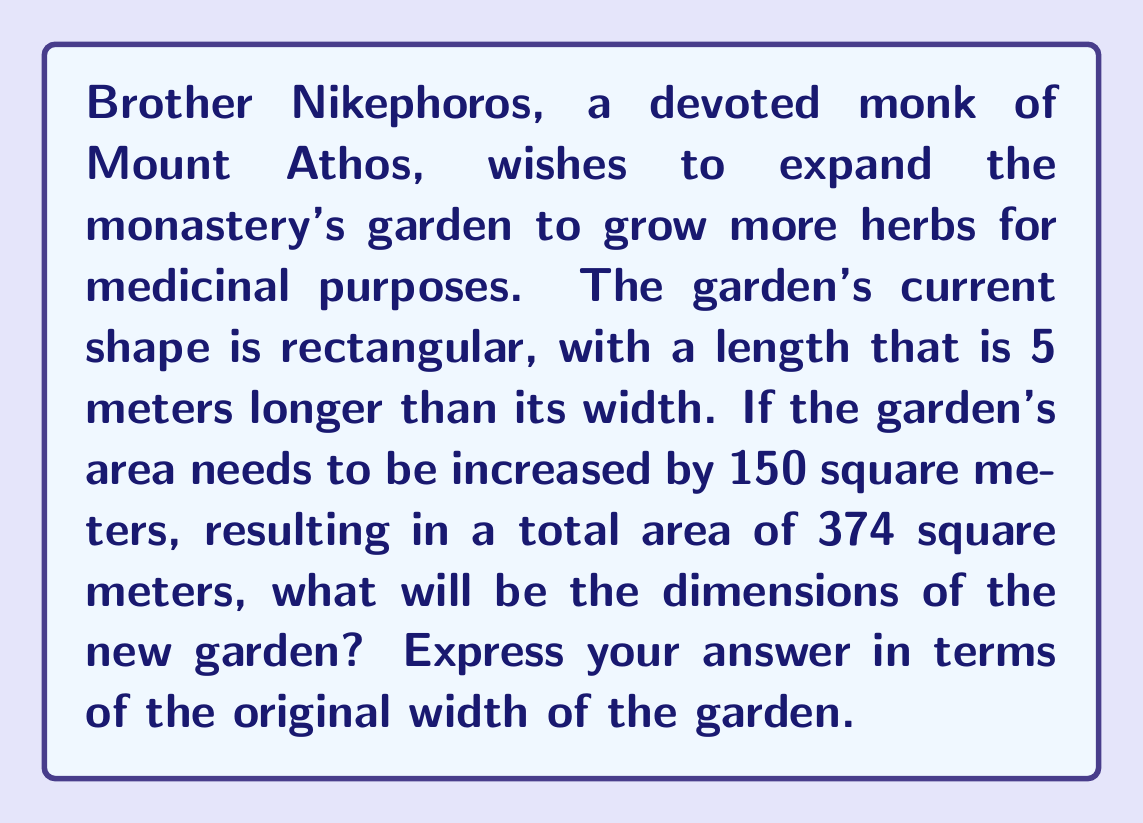Can you solve this math problem? Let's approach this step-by-step:

1) Let $x$ be the original width of the garden in meters. Then the length is $x + 5$ meters.

2) The original area of the garden can be expressed as:
   $A = x(x + 5)$

3) We know that the new area is 374 square meters, which is 150 square meters more than the original area. So we can set up the equation:
   $x(x + 5) + 150 = 374$

4) Expand the left side of the equation:
   $x^2 + 5x + 150 = 374$

5) Subtract 374 from both sides to get the quadratic equation in standard form:
   $x^2 + 5x - 224 = 0$

6) We can solve this using the quadratic formula: $x = \frac{-b \pm \sqrt{b^2 - 4ac}}{2a}$
   Where $a = 1$, $b = 5$, and $c = -224$

7) Plugging in these values:
   $x = \frac{-5 \pm \sqrt{5^2 - 4(1)(-224)}}{2(1)}$
   $= \frac{-5 \pm \sqrt{25 + 896}}{2}$
   $= \frac{-5 \pm \sqrt{921}}{2}$
   $= \frac{-5 \pm 30.35}{2}$

8) This gives us two solutions:
   $x = \frac{-5 + 30.35}{2} = 12.675$ or $x = \frac{-5 - 30.35}{2} = -17.675$

9) Since width cannot be negative, we take the positive solution: $x = 12.675$ meters

10) The new length will be $12.675 + 5 = 17.675$ meters

Therefore, the new dimensions of the garden will be approximately 12.675 meters wide and 17.675 meters long.
Answer: The new dimensions of the garden will be approximately $12.675$ meters wide and $17.675$ meters long, where the width increased by $12.675 - x$ meters and the length increased by $12.675 - x + 5$ meters, with $x$ being the original width of the garden. 